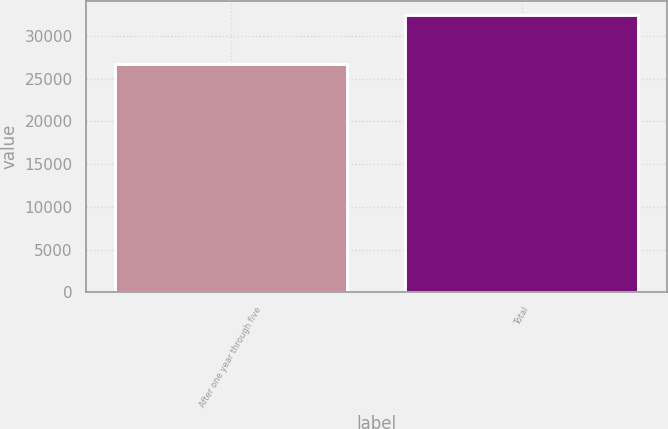<chart> <loc_0><loc_0><loc_500><loc_500><bar_chart><fcel>After one year through five<fcel>Total<nl><fcel>26740<fcel>32508<nl></chart> 